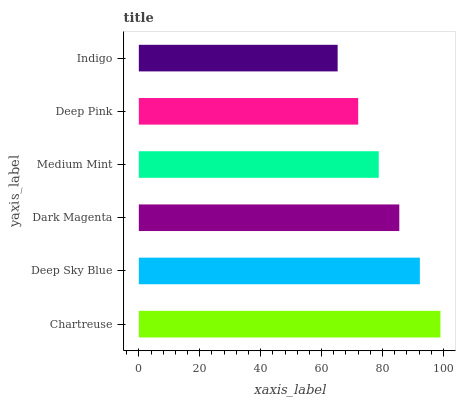Is Indigo the minimum?
Answer yes or no. Yes. Is Chartreuse the maximum?
Answer yes or no. Yes. Is Deep Sky Blue the minimum?
Answer yes or no. No. Is Deep Sky Blue the maximum?
Answer yes or no. No. Is Chartreuse greater than Deep Sky Blue?
Answer yes or no. Yes. Is Deep Sky Blue less than Chartreuse?
Answer yes or no. Yes. Is Deep Sky Blue greater than Chartreuse?
Answer yes or no. No. Is Chartreuse less than Deep Sky Blue?
Answer yes or no. No. Is Dark Magenta the high median?
Answer yes or no. Yes. Is Medium Mint the low median?
Answer yes or no. Yes. Is Deep Sky Blue the high median?
Answer yes or no. No. Is Indigo the low median?
Answer yes or no. No. 